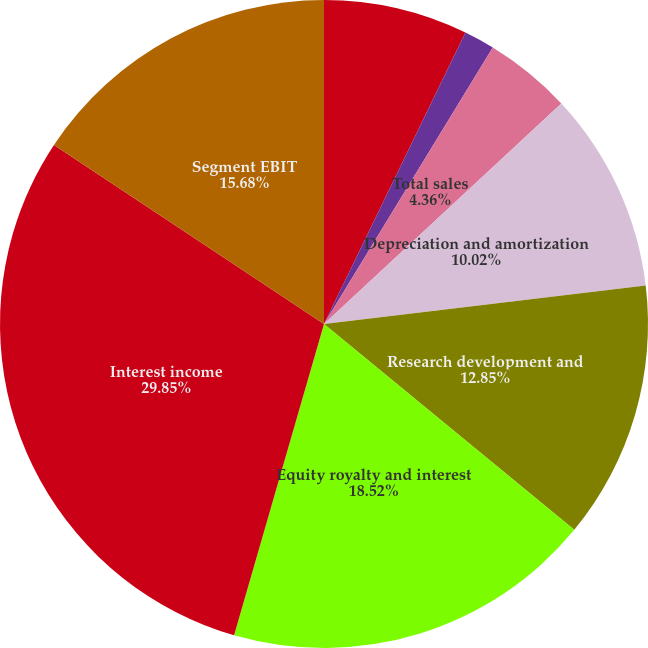Convert chart to OTSL. <chart><loc_0><loc_0><loc_500><loc_500><pie_chart><fcel>External sales<fcel>Intersegment sales<fcel>Total sales<fcel>Depreciation and amortization<fcel>Research development and<fcel>Equity royalty and interest<fcel>Interest income<fcel>Segment EBIT<nl><fcel>7.19%<fcel>1.53%<fcel>4.36%<fcel>10.02%<fcel>12.85%<fcel>18.52%<fcel>29.84%<fcel>15.68%<nl></chart> 